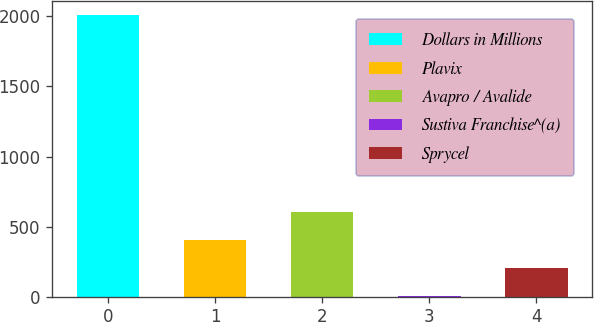<chart> <loc_0><loc_0><loc_500><loc_500><bar_chart><fcel>Dollars in Millions<fcel>Plavix<fcel>Avapro / Avalide<fcel>Sustiva Franchise^(a)<fcel>Sprycel<nl><fcel>2012<fcel>403.2<fcel>604.3<fcel>1<fcel>202.1<nl></chart> 